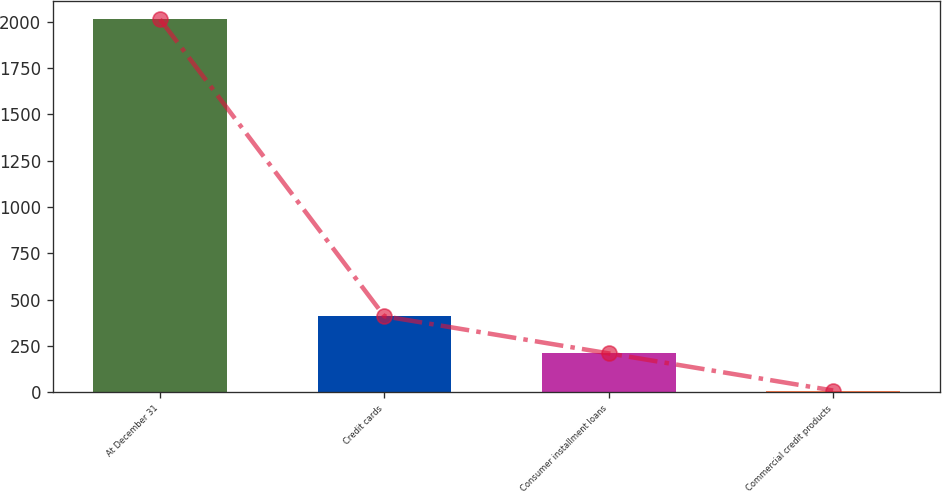<chart> <loc_0><loc_0><loc_500><loc_500><bar_chart><fcel>At December 31<fcel>Credit cards<fcel>Consumer installment loans<fcel>Commercial credit products<nl><fcel>2014<fcel>409.68<fcel>209.14<fcel>8.6<nl></chart> 